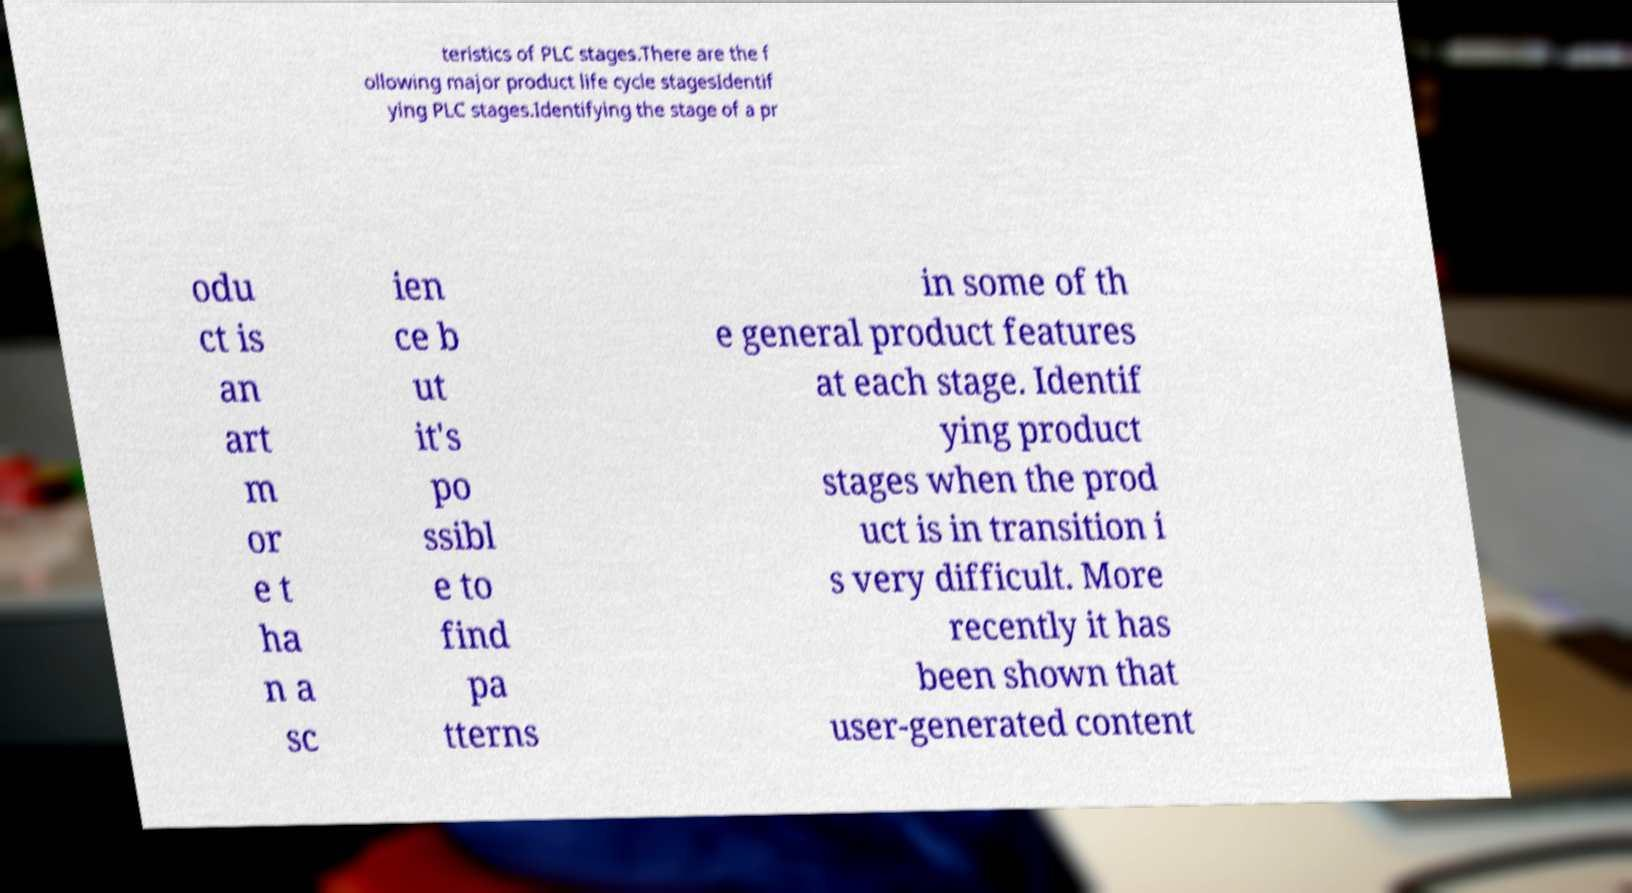I need the written content from this picture converted into text. Can you do that? teristics of PLC stages.There are the f ollowing major product life cycle stagesIdentif ying PLC stages.Identifying the stage of a pr odu ct is an art m or e t ha n a sc ien ce b ut it's po ssibl e to find pa tterns in some of th e general product features at each stage. Identif ying product stages when the prod uct is in transition i s very difficult. More recently it has been shown that user-generated content 